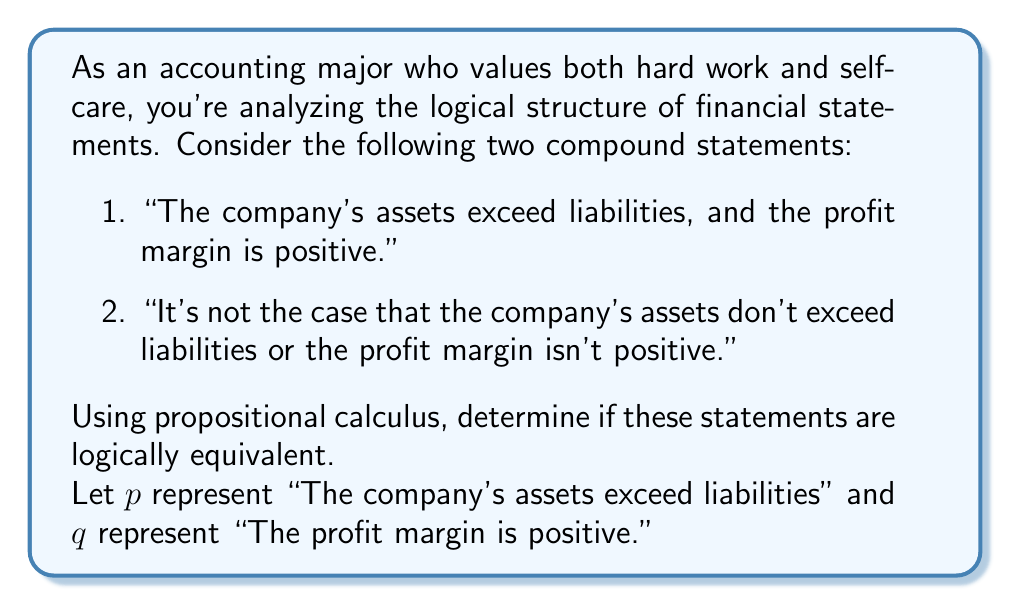What is the answer to this math problem? To determine if the two statements are logically equivalent, we'll use propositional calculus to express them symbolically and then compare their truth tables.

1. The first statement can be represented as: $p \land q$

2. The second statement can be represented as: $\neg(\neg p \lor \neg q)$

To prove logical equivalence, we need to show that these statements always have the same truth value. We can do this by applying De Morgan's laws or by constructing a truth table.

Using De Morgan's laws:
$$\neg(\neg p \lor \neg q) \equiv \neg(\neg p) \land \neg(\neg q) \equiv p \land q$$

This algebraic manipulation suggests that the statements are equivalent, but let's verify with a truth table:

$$\begin{array}{|c|c|c|c|c|c|}
\hline
p & q & p \land q & \neg p & \neg q & \neg p \lor \neg q & \neg(\neg p \lor \neg q) \\
\hline
T & T & T & F & F & F & T \\
T & F & F & F & T & T & F \\
F & T & F & T & F & T & F \\
F & F & F & T & T & T & F \\
\hline
\end{array}$$

As we can see, the truth values in the $p \land q$ column are identical to those in the $\neg(\neg p \lor \neg q)$ column for all possible combinations of $p$ and $q$. This confirms that the two statements are indeed logically equivalent.

In the context of financial analysis, this equivalence means that asserting both positive conditions (assets exceeding liabilities AND positive profit margin) is logically the same as denying that either of these conditions is false. This understanding can be valuable when interpreting complex financial statements or audit reports.
Answer: The two compound statements are logically equivalent. Symbolically, $p \land q \equiv \neg(\neg p \lor \neg q)$. 